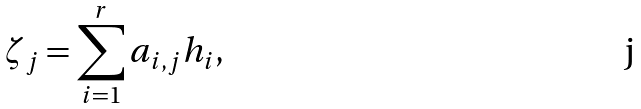<formula> <loc_0><loc_0><loc_500><loc_500>\zeta _ { j } = \sum _ { i = 1 } ^ { r } a _ { i , j } h _ { i } ,</formula> 